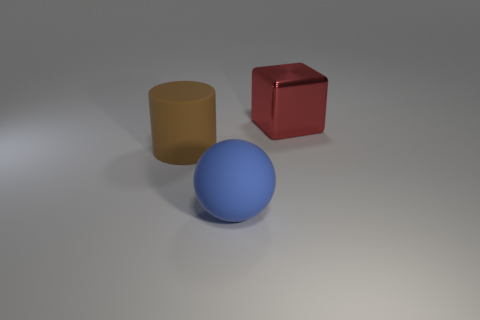Subtract 1 cylinders. How many cylinders are left? 0 Subtract all brown balls. Subtract all brown cubes. How many balls are left? 1 Subtract all spheres. Subtract all large balls. How many objects are left? 1 Add 1 blue spheres. How many blue spheres are left? 2 Add 3 large brown things. How many large brown things exist? 4 Add 1 small brown metallic things. How many objects exist? 4 Subtract 1 blue spheres. How many objects are left? 2 Subtract all blocks. How many objects are left? 2 